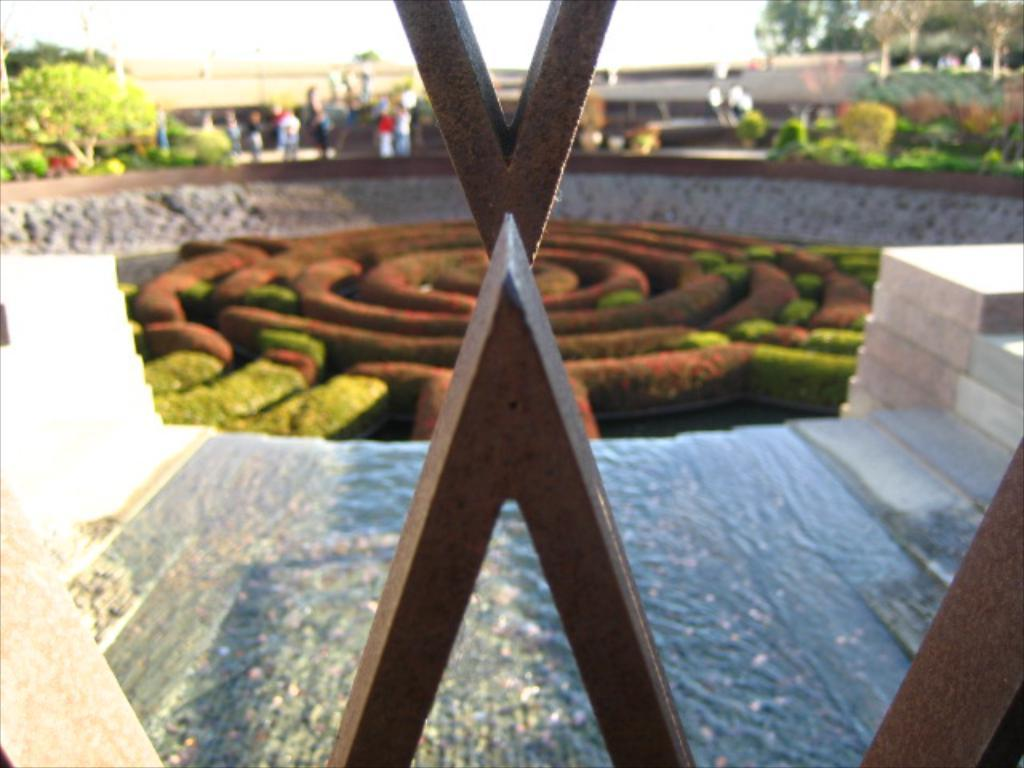What type of outdoor space is shown in the image? There is a garden in the image. What architectural feature can be seen in the image? There are stairs in the image. Who or what is present in the image? There is a group of persons in the image. What type of structure is visible in the image? There is a building in the image. What type of vegetation is present in the image? There are trees in the image. What is visible in the background of the image? The sky is visible in the image. Where is the bed located in the image? There is no bed present in the image. What type of birth can be seen taking place in the image? There is no birth taking place in the image. 